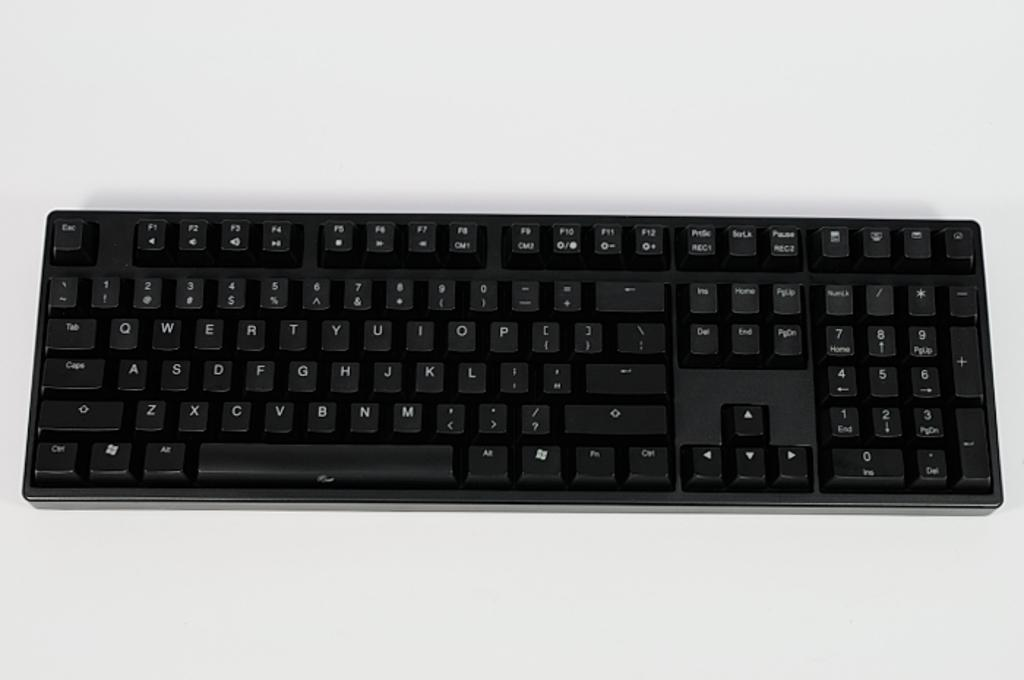Provide a one-sentence caption for the provided image. Standard black keyboard with an ESC button on the top left. 